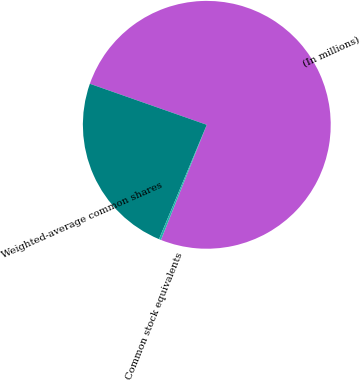Convert chart to OTSL. <chart><loc_0><loc_0><loc_500><loc_500><pie_chart><fcel>(In millions)<fcel>Weighted-average common shares<fcel>Common stock equivalents<nl><fcel>75.66%<fcel>24.07%<fcel>0.27%<nl></chart> 